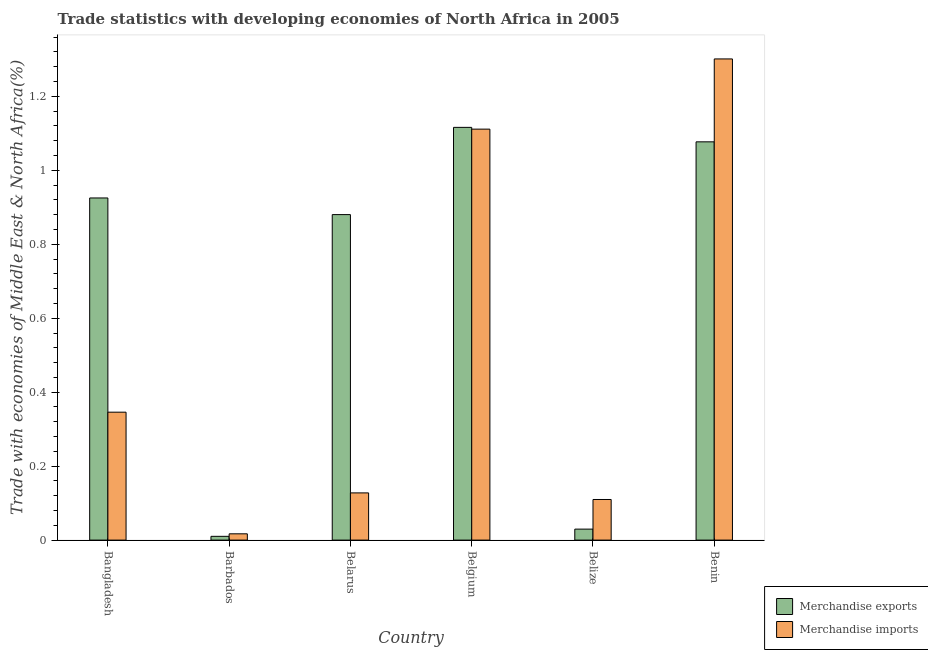How many groups of bars are there?
Keep it short and to the point. 6. How many bars are there on the 2nd tick from the left?
Your answer should be compact. 2. What is the label of the 1st group of bars from the left?
Keep it short and to the point. Bangladesh. What is the merchandise exports in Belarus?
Offer a terse response. 0.88. Across all countries, what is the maximum merchandise imports?
Provide a succinct answer. 1.3. Across all countries, what is the minimum merchandise imports?
Provide a short and direct response. 0.02. In which country was the merchandise imports maximum?
Give a very brief answer. Benin. In which country was the merchandise imports minimum?
Provide a succinct answer. Barbados. What is the total merchandise imports in the graph?
Your response must be concise. 3.01. What is the difference between the merchandise exports in Bangladesh and that in Benin?
Your response must be concise. -0.15. What is the difference between the merchandise exports in Benin and the merchandise imports in Belarus?
Provide a short and direct response. 0.95. What is the average merchandise imports per country?
Offer a terse response. 0.5. What is the difference between the merchandise imports and merchandise exports in Benin?
Ensure brevity in your answer.  0.22. What is the ratio of the merchandise exports in Bangladesh to that in Benin?
Provide a succinct answer. 0.86. What is the difference between the highest and the second highest merchandise exports?
Offer a very short reply. 0.04. What is the difference between the highest and the lowest merchandise imports?
Give a very brief answer. 1.28. In how many countries, is the merchandise imports greater than the average merchandise imports taken over all countries?
Your answer should be compact. 2. Is the sum of the merchandise imports in Barbados and Belarus greater than the maximum merchandise exports across all countries?
Ensure brevity in your answer.  No. What does the 1st bar from the left in Bangladesh represents?
Ensure brevity in your answer.  Merchandise exports. What does the 2nd bar from the right in Belize represents?
Your answer should be compact. Merchandise exports. How many bars are there?
Provide a short and direct response. 12. How many countries are there in the graph?
Offer a very short reply. 6. Does the graph contain any zero values?
Offer a terse response. No. Does the graph contain grids?
Make the answer very short. No. How many legend labels are there?
Your answer should be compact. 2. What is the title of the graph?
Offer a very short reply. Trade statistics with developing economies of North Africa in 2005. Does "Drinking water services" appear as one of the legend labels in the graph?
Make the answer very short. No. What is the label or title of the X-axis?
Your answer should be very brief. Country. What is the label or title of the Y-axis?
Keep it short and to the point. Trade with economies of Middle East & North Africa(%). What is the Trade with economies of Middle East & North Africa(%) of Merchandise exports in Bangladesh?
Your answer should be compact. 0.93. What is the Trade with economies of Middle East & North Africa(%) in Merchandise imports in Bangladesh?
Give a very brief answer. 0.35. What is the Trade with economies of Middle East & North Africa(%) in Merchandise exports in Barbados?
Ensure brevity in your answer.  0.01. What is the Trade with economies of Middle East & North Africa(%) in Merchandise imports in Barbados?
Your answer should be compact. 0.02. What is the Trade with economies of Middle East & North Africa(%) of Merchandise exports in Belarus?
Offer a terse response. 0.88. What is the Trade with economies of Middle East & North Africa(%) of Merchandise imports in Belarus?
Your response must be concise. 0.13. What is the Trade with economies of Middle East & North Africa(%) of Merchandise exports in Belgium?
Ensure brevity in your answer.  1.12. What is the Trade with economies of Middle East & North Africa(%) in Merchandise imports in Belgium?
Offer a very short reply. 1.11. What is the Trade with economies of Middle East & North Africa(%) in Merchandise exports in Belize?
Provide a short and direct response. 0.03. What is the Trade with economies of Middle East & North Africa(%) in Merchandise imports in Belize?
Give a very brief answer. 0.11. What is the Trade with economies of Middle East & North Africa(%) of Merchandise exports in Benin?
Your answer should be very brief. 1.08. What is the Trade with economies of Middle East & North Africa(%) of Merchandise imports in Benin?
Your answer should be very brief. 1.3. Across all countries, what is the maximum Trade with economies of Middle East & North Africa(%) in Merchandise exports?
Offer a very short reply. 1.12. Across all countries, what is the maximum Trade with economies of Middle East & North Africa(%) of Merchandise imports?
Your answer should be very brief. 1.3. Across all countries, what is the minimum Trade with economies of Middle East & North Africa(%) in Merchandise exports?
Provide a short and direct response. 0.01. Across all countries, what is the minimum Trade with economies of Middle East & North Africa(%) in Merchandise imports?
Give a very brief answer. 0.02. What is the total Trade with economies of Middle East & North Africa(%) of Merchandise exports in the graph?
Provide a succinct answer. 4.04. What is the total Trade with economies of Middle East & North Africa(%) in Merchandise imports in the graph?
Provide a succinct answer. 3.01. What is the difference between the Trade with economies of Middle East & North Africa(%) of Merchandise exports in Bangladesh and that in Barbados?
Your answer should be compact. 0.92. What is the difference between the Trade with economies of Middle East & North Africa(%) in Merchandise imports in Bangladesh and that in Barbados?
Keep it short and to the point. 0.33. What is the difference between the Trade with economies of Middle East & North Africa(%) of Merchandise exports in Bangladesh and that in Belarus?
Give a very brief answer. 0.04. What is the difference between the Trade with economies of Middle East & North Africa(%) of Merchandise imports in Bangladesh and that in Belarus?
Your answer should be compact. 0.22. What is the difference between the Trade with economies of Middle East & North Africa(%) of Merchandise exports in Bangladesh and that in Belgium?
Offer a very short reply. -0.19. What is the difference between the Trade with economies of Middle East & North Africa(%) in Merchandise imports in Bangladesh and that in Belgium?
Provide a short and direct response. -0.77. What is the difference between the Trade with economies of Middle East & North Africa(%) in Merchandise exports in Bangladesh and that in Belize?
Your answer should be compact. 0.9. What is the difference between the Trade with economies of Middle East & North Africa(%) of Merchandise imports in Bangladesh and that in Belize?
Your answer should be very brief. 0.24. What is the difference between the Trade with economies of Middle East & North Africa(%) of Merchandise exports in Bangladesh and that in Benin?
Give a very brief answer. -0.15. What is the difference between the Trade with economies of Middle East & North Africa(%) in Merchandise imports in Bangladesh and that in Benin?
Provide a short and direct response. -0.96. What is the difference between the Trade with economies of Middle East & North Africa(%) in Merchandise exports in Barbados and that in Belarus?
Provide a short and direct response. -0.87. What is the difference between the Trade with economies of Middle East & North Africa(%) of Merchandise imports in Barbados and that in Belarus?
Ensure brevity in your answer.  -0.11. What is the difference between the Trade with economies of Middle East & North Africa(%) of Merchandise exports in Barbados and that in Belgium?
Your answer should be compact. -1.11. What is the difference between the Trade with economies of Middle East & North Africa(%) in Merchandise imports in Barbados and that in Belgium?
Keep it short and to the point. -1.09. What is the difference between the Trade with economies of Middle East & North Africa(%) of Merchandise exports in Barbados and that in Belize?
Your answer should be very brief. -0.02. What is the difference between the Trade with economies of Middle East & North Africa(%) in Merchandise imports in Barbados and that in Belize?
Make the answer very short. -0.09. What is the difference between the Trade with economies of Middle East & North Africa(%) of Merchandise exports in Barbados and that in Benin?
Your answer should be very brief. -1.07. What is the difference between the Trade with economies of Middle East & North Africa(%) in Merchandise imports in Barbados and that in Benin?
Give a very brief answer. -1.28. What is the difference between the Trade with economies of Middle East & North Africa(%) of Merchandise exports in Belarus and that in Belgium?
Give a very brief answer. -0.24. What is the difference between the Trade with economies of Middle East & North Africa(%) in Merchandise imports in Belarus and that in Belgium?
Make the answer very short. -0.98. What is the difference between the Trade with economies of Middle East & North Africa(%) of Merchandise exports in Belarus and that in Belize?
Provide a short and direct response. 0.85. What is the difference between the Trade with economies of Middle East & North Africa(%) in Merchandise imports in Belarus and that in Belize?
Your answer should be compact. 0.02. What is the difference between the Trade with economies of Middle East & North Africa(%) in Merchandise exports in Belarus and that in Benin?
Offer a very short reply. -0.2. What is the difference between the Trade with economies of Middle East & North Africa(%) in Merchandise imports in Belarus and that in Benin?
Offer a terse response. -1.17. What is the difference between the Trade with economies of Middle East & North Africa(%) of Merchandise exports in Belgium and that in Belize?
Give a very brief answer. 1.09. What is the difference between the Trade with economies of Middle East & North Africa(%) in Merchandise exports in Belgium and that in Benin?
Make the answer very short. 0.04. What is the difference between the Trade with economies of Middle East & North Africa(%) of Merchandise imports in Belgium and that in Benin?
Your response must be concise. -0.19. What is the difference between the Trade with economies of Middle East & North Africa(%) of Merchandise exports in Belize and that in Benin?
Offer a terse response. -1.05. What is the difference between the Trade with economies of Middle East & North Africa(%) in Merchandise imports in Belize and that in Benin?
Make the answer very short. -1.19. What is the difference between the Trade with economies of Middle East & North Africa(%) of Merchandise exports in Bangladesh and the Trade with economies of Middle East & North Africa(%) of Merchandise imports in Barbados?
Give a very brief answer. 0.91. What is the difference between the Trade with economies of Middle East & North Africa(%) of Merchandise exports in Bangladesh and the Trade with economies of Middle East & North Africa(%) of Merchandise imports in Belarus?
Your answer should be very brief. 0.8. What is the difference between the Trade with economies of Middle East & North Africa(%) of Merchandise exports in Bangladesh and the Trade with economies of Middle East & North Africa(%) of Merchandise imports in Belgium?
Your answer should be compact. -0.19. What is the difference between the Trade with economies of Middle East & North Africa(%) in Merchandise exports in Bangladesh and the Trade with economies of Middle East & North Africa(%) in Merchandise imports in Belize?
Your response must be concise. 0.82. What is the difference between the Trade with economies of Middle East & North Africa(%) in Merchandise exports in Bangladesh and the Trade with economies of Middle East & North Africa(%) in Merchandise imports in Benin?
Offer a terse response. -0.38. What is the difference between the Trade with economies of Middle East & North Africa(%) of Merchandise exports in Barbados and the Trade with economies of Middle East & North Africa(%) of Merchandise imports in Belarus?
Give a very brief answer. -0.12. What is the difference between the Trade with economies of Middle East & North Africa(%) of Merchandise exports in Barbados and the Trade with economies of Middle East & North Africa(%) of Merchandise imports in Belgium?
Offer a very short reply. -1.1. What is the difference between the Trade with economies of Middle East & North Africa(%) in Merchandise exports in Barbados and the Trade with economies of Middle East & North Africa(%) in Merchandise imports in Belize?
Your answer should be compact. -0.1. What is the difference between the Trade with economies of Middle East & North Africa(%) of Merchandise exports in Barbados and the Trade with economies of Middle East & North Africa(%) of Merchandise imports in Benin?
Make the answer very short. -1.29. What is the difference between the Trade with economies of Middle East & North Africa(%) in Merchandise exports in Belarus and the Trade with economies of Middle East & North Africa(%) in Merchandise imports in Belgium?
Your answer should be very brief. -0.23. What is the difference between the Trade with economies of Middle East & North Africa(%) of Merchandise exports in Belarus and the Trade with economies of Middle East & North Africa(%) of Merchandise imports in Belize?
Your answer should be very brief. 0.77. What is the difference between the Trade with economies of Middle East & North Africa(%) in Merchandise exports in Belarus and the Trade with economies of Middle East & North Africa(%) in Merchandise imports in Benin?
Keep it short and to the point. -0.42. What is the difference between the Trade with economies of Middle East & North Africa(%) of Merchandise exports in Belgium and the Trade with economies of Middle East & North Africa(%) of Merchandise imports in Benin?
Your answer should be very brief. -0.18. What is the difference between the Trade with economies of Middle East & North Africa(%) of Merchandise exports in Belize and the Trade with economies of Middle East & North Africa(%) of Merchandise imports in Benin?
Offer a terse response. -1.27. What is the average Trade with economies of Middle East & North Africa(%) of Merchandise exports per country?
Keep it short and to the point. 0.67. What is the average Trade with economies of Middle East & North Africa(%) in Merchandise imports per country?
Offer a very short reply. 0.5. What is the difference between the Trade with economies of Middle East & North Africa(%) of Merchandise exports and Trade with economies of Middle East & North Africa(%) of Merchandise imports in Bangladesh?
Make the answer very short. 0.58. What is the difference between the Trade with economies of Middle East & North Africa(%) of Merchandise exports and Trade with economies of Middle East & North Africa(%) of Merchandise imports in Barbados?
Provide a succinct answer. -0.01. What is the difference between the Trade with economies of Middle East & North Africa(%) of Merchandise exports and Trade with economies of Middle East & North Africa(%) of Merchandise imports in Belarus?
Your answer should be compact. 0.75. What is the difference between the Trade with economies of Middle East & North Africa(%) in Merchandise exports and Trade with economies of Middle East & North Africa(%) in Merchandise imports in Belgium?
Make the answer very short. 0. What is the difference between the Trade with economies of Middle East & North Africa(%) in Merchandise exports and Trade with economies of Middle East & North Africa(%) in Merchandise imports in Belize?
Give a very brief answer. -0.08. What is the difference between the Trade with economies of Middle East & North Africa(%) of Merchandise exports and Trade with economies of Middle East & North Africa(%) of Merchandise imports in Benin?
Give a very brief answer. -0.22. What is the ratio of the Trade with economies of Middle East & North Africa(%) of Merchandise exports in Bangladesh to that in Barbados?
Make the answer very short. 90.94. What is the ratio of the Trade with economies of Middle East & North Africa(%) of Merchandise imports in Bangladesh to that in Barbados?
Your response must be concise. 20.37. What is the ratio of the Trade with economies of Middle East & North Africa(%) in Merchandise exports in Bangladesh to that in Belarus?
Provide a short and direct response. 1.05. What is the ratio of the Trade with economies of Middle East & North Africa(%) of Merchandise imports in Bangladesh to that in Belarus?
Your answer should be very brief. 2.71. What is the ratio of the Trade with economies of Middle East & North Africa(%) in Merchandise exports in Bangladesh to that in Belgium?
Offer a terse response. 0.83. What is the ratio of the Trade with economies of Middle East & North Africa(%) of Merchandise imports in Bangladesh to that in Belgium?
Make the answer very short. 0.31. What is the ratio of the Trade with economies of Middle East & North Africa(%) in Merchandise exports in Bangladesh to that in Belize?
Give a very brief answer. 31.13. What is the ratio of the Trade with economies of Middle East & North Africa(%) of Merchandise imports in Bangladesh to that in Belize?
Provide a short and direct response. 3.15. What is the ratio of the Trade with economies of Middle East & North Africa(%) of Merchandise exports in Bangladesh to that in Benin?
Keep it short and to the point. 0.86. What is the ratio of the Trade with economies of Middle East & North Africa(%) in Merchandise imports in Bangladesh to that in Benin?
Your response must be concise. 0.27. What is the ratio of the Trade with economies of Middle East & North Africa(%) in Merchandise exports in Barbados to that in Belarus?
Keep it short and to the point. 0.01. What is the ratio of the Trade with economies of Middle East & North Africa(%) of Merchandise imports in Barbados to that in Belarus?
Make the answer very short. 0.13. What is the ratio of the Trade with economies of Middle East & North Africa(%) in Merchandise exports in Barbados to that in Belgium?
Offer a terse response. 0.01. What is the ratio of the Trade with economies of Middle East & North Africa(%) in Merchandise imports in Barbados to that in Belgium?
Offer a terse response. 0.02. What is the ratio of the Trade with economies of Middle East & North Africa(%) of Merchandise exports in Barbados to that in Belize?
Give a very brief answer. 0.34. What is the ratio of the Trade with economies of Middle East & North Africa(%) of Merchandise imports in Barbados to that in Belize?
Offer a very short reply. 0.15. What is the ratio of the Trade with economies of Middle East & North Africa(%) in Merchandise exports in Barbados to that in Benin?
Make the answer very short. 0.01. What is the ratio of the Trade with economies of Middle East & North Africa(%) of Merchandise imports in Barbados to that in Benin?
Your answer should be compact. 0.01. What is the ratio of the Trade with economies of Middle East & North Africa(%) of Merchandise exports in Belarus to that in Belgium?
Make the answer very short. 0.79. What is the ratio of the Trade with economies of Middle East & North Africa(%) in Merchandise imports in Belarus to that in Belgium?
Your response must be concise. 0.11. What is the ratio of the Trade with economies of Middle East & North Africa(%) in Merchandise exports in Belarus to that in Belize?
Your answer should be compact. 29.62. What is the ratio of the Trade with economies of Middle East & North Africa(%) in Merchandise imports in Belarus to that in Belize?
Offer a terse response. 1.16. What is the ratio of the Trade with economies of Middle East & North Africa(%) in Merchandise exports in Belarus to that in Benin?
Ensure brevity in your answer.  0.82. What is the ratio of the Trade with economies of Middle East & North Africa(%) of Merchandise imports in Belarus to that in Benin?
Ensure brevity in your answer.  0.1. What is the ratio of the Trade with economies of Middle East & North Africa(%) in Merchandise exports in Belgium to that in Belize?
Make the answer very short. 37.56. What is the ratio of the Trade with economies of Middle East & North Africa(%) in Merchandise imports in Belgium to that in Belize?
Ensure brevity in your answer.  10.12. What is the ratio of the Trade with economies of Middle East & North Africa(%) in Merchandise exports in Belgium to that in Benin?
Provide a succinct answer. 1.04. What is the ratio of the Trade with economies of Middle East & North Africa(%) of Merchandise imports in Belgium to that in Benin?
Keep it short and to the point. 0.85. What is the ratio of the Trade with economies of Middle East & North Africa(%) of Merchandise exports in Belize to that in Benin?
Provide a short and direct response. 0.03. What is the ratio of the Trade with economies of Middle East & North Africa(%) of Merchandise imports in Belize to that in Benin?
Ensure brevity in your answer.  0.08. What is the difference between the highest and the second highest Trade with economies of Middle East & North Africa(%) of Merchandise exports?
Offer a terse response. 0.04. What is the difference between the highest and the second highest Trade with economies of Middle East & North Africa(%) in Merchandise imports?
Make the answer very short. 0.19. What is the difference between the highest and the lowest Trade with economies of Middle East & North Africa(%) of Merchandise exports?
Provide a succinct answer. 1.11. What is the difference between the highest and the lowest Trade with economies of Middle East & North Africa(%) of Merchandise imports?
Provide a short and direct response. 1.28. 